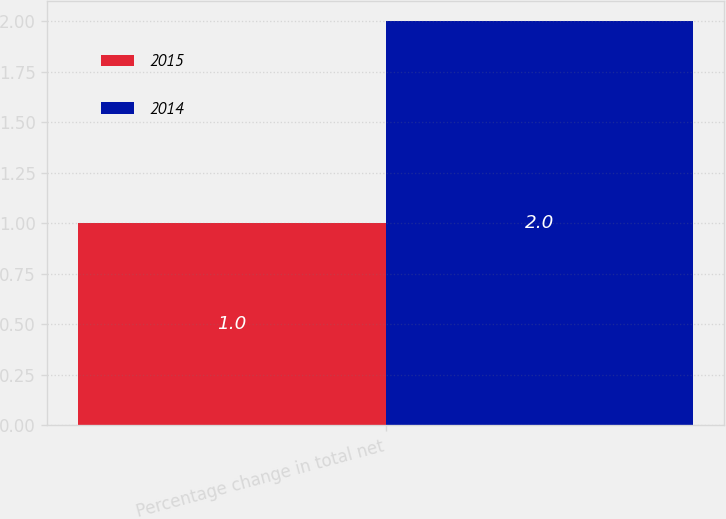Convert chart to OTSL. <chart><loc_0><loc_0><loc_500><loc_500><stacked_bar_chart><ecel><fcel>Percentage change in total net<nl><fcel>2015<fcel>1<nl><fcel>2014<fcel>2<nl></chart> 